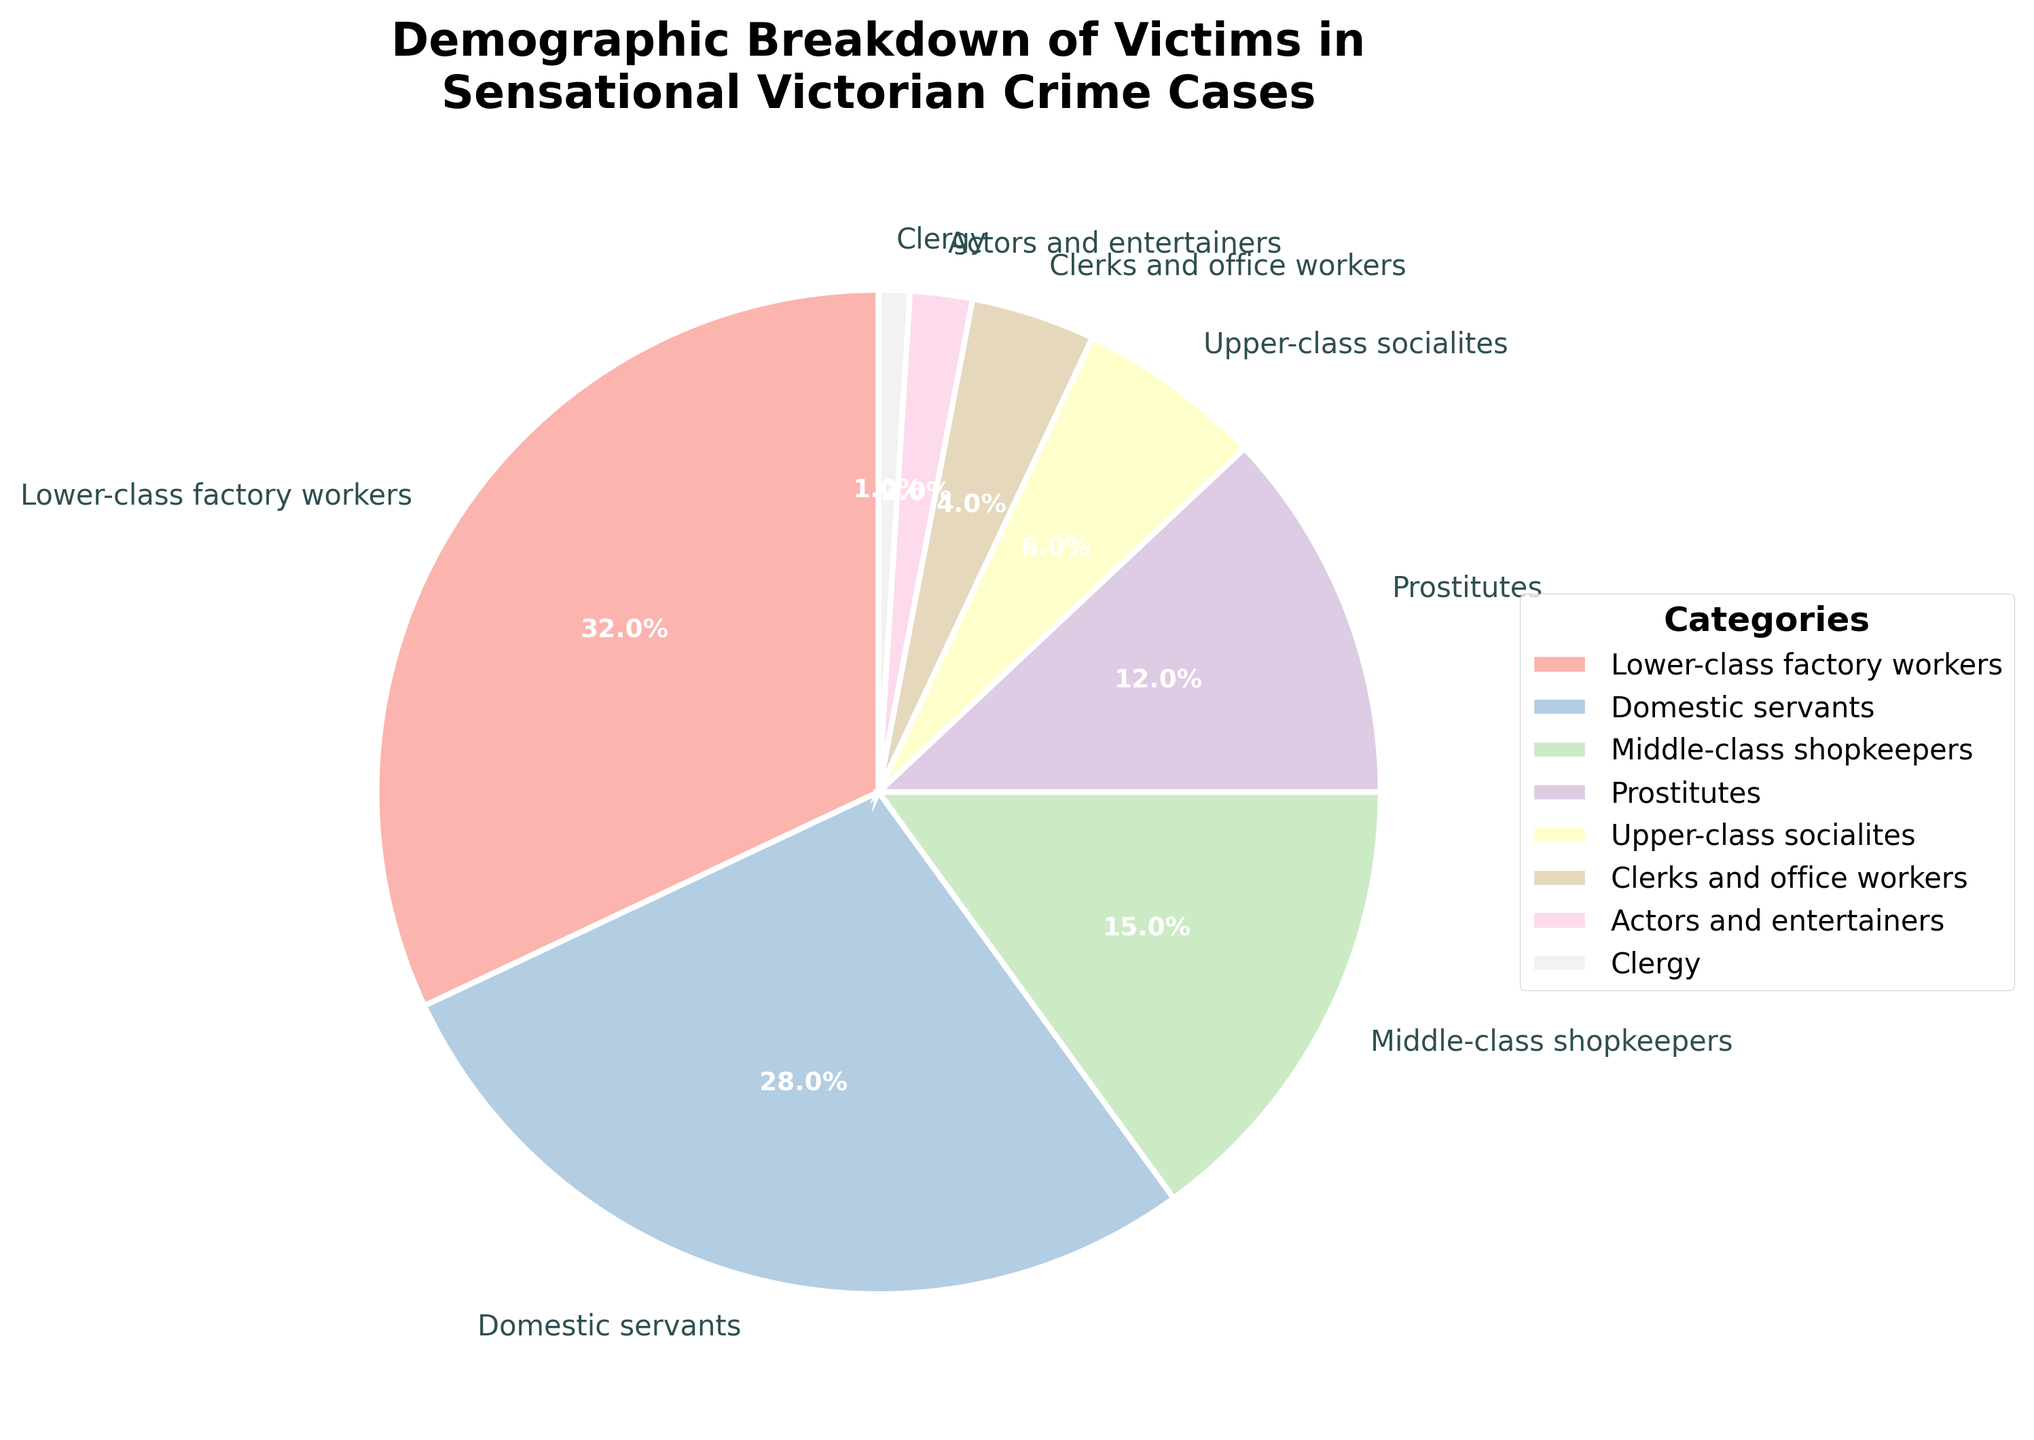Which category has the highest percentage of victims? The category labeled "Lower-class factory workers" has the highest percentage in the figure.
Answer: Lower-class factory workers What is the combined percentage of victims who are either domestic servants or middle-class shopkeepers? The percentage of domestic servants is 28%, and the percentage of middle-class shopkeepers is 15%. Adding these together, 28% + 15% = 43%.
Answer: 43% Are there more victims who are clergy or actors and entertainers? The percentage of clergy victims is 1%, while actors and entertainers account for 2%. Since 2% is greater than 1%, actors and entertainers have more victims.
Answer: Actors and entertainers What is the difference in percentage between lower-class factory workers and upper-class socialites? Lower-class factory workers have a percentage of 32%, and upper-class socialites have 6%. The difference is calculated as 32% - 6% = 26%.
Answer: 26% Do the clerks and office workers have a higher or lower victim percentage than upper-class socialites? The clerks and office workers have a percentage of 4%, whereas upper-class socialites have 6%. Since 4% is less than 6%, clerks and office workers have a lower victim percentage.
Answer: Lower Which category has a smaller percentage of victims compared to domestic servants but larger than upper-class socialites? Domestic servants have a percentage of 28%, and upper-class socialites have 6%. The middle-class shopkeepers have 15%, which is more than 6% but less than 28%.
Answer: Middle-class shopkeepers What percentage of victims belongs to the lower-class factory workers and prostitutes combined? The lower-class factory workers account for 32%, and prostitutes account for 12%. Adding these together gives 32% + 12% = 44%.
Answer: 44% Is the percentage of domestic servants closer to that of lower-class factory workers or middle-class shopkeepers? The percentage of domestic servants is 28%. Lower-class factory workers have 32%, and middle-class shopkeepers have 15%. The difference to lower-class factory workers is 32% - 28% = 4%, while the difference to middle-class shopkeepers is 28% - 15% = 13%. The domestic servants are closer to the lower-class factory workers.
Answer: Lower-class factory workers 